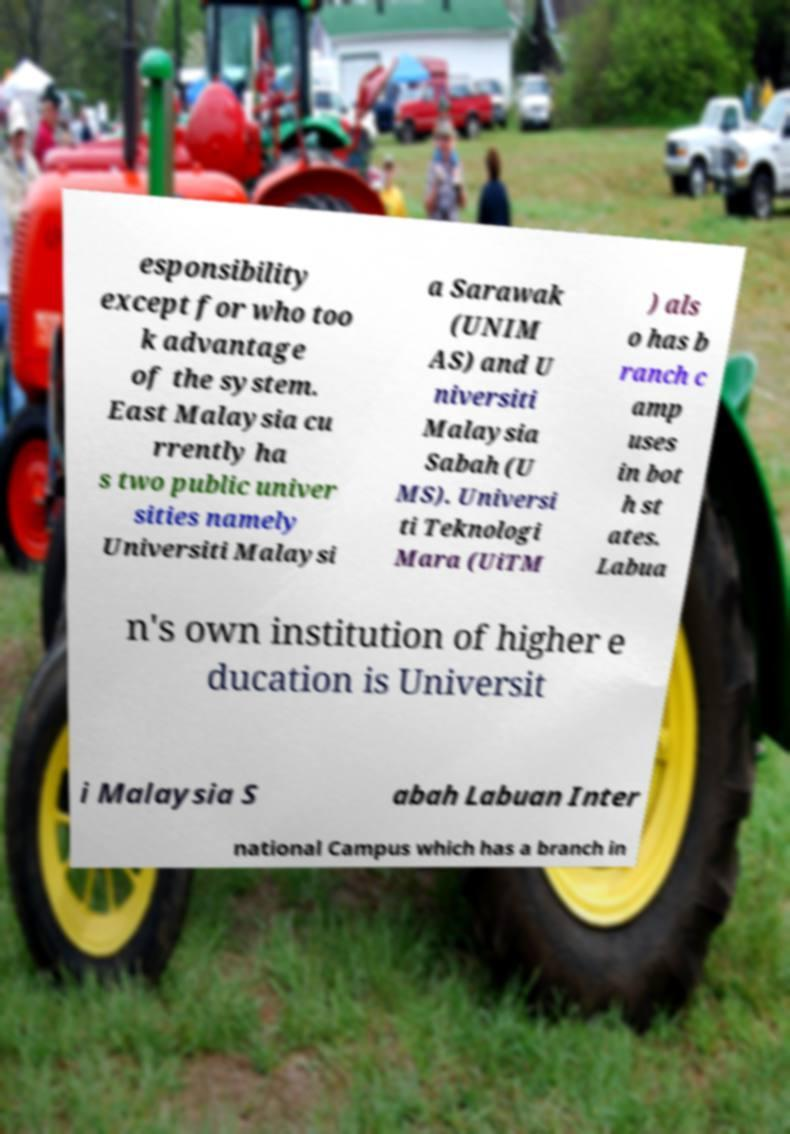There's text embedded in this image that I need extracted. Can you transcribe it verbatim? esponsibility except for who too k advantage of the system. East Malaysia cu rrently ha s two public univer sities namely Universiti Malaysi a Sarawak (UNIM AS) and U niversiti Malaysia Sabah (U MS). Universi ti Teknologi Mara (UiTM ) als o has b ranch c amp uses in bot h st ates. Labua n's own institution of higher e ducation is Universit i Malaysia S abah Labuan Inter national Campus which has a branch in 